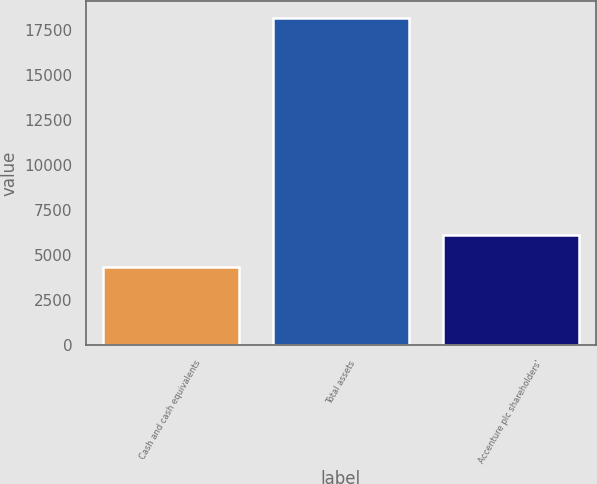Convert chart to OTSL. <chart><loc_0><loc_0><loc_500><loc_500><bar_chart><fcel>Cash and cash equivalents<fcel>Total assets<fcel>Accenture plc shareholders'<nl><fcel>4361<fcel>18203<fcel>6134<nl></chart> 